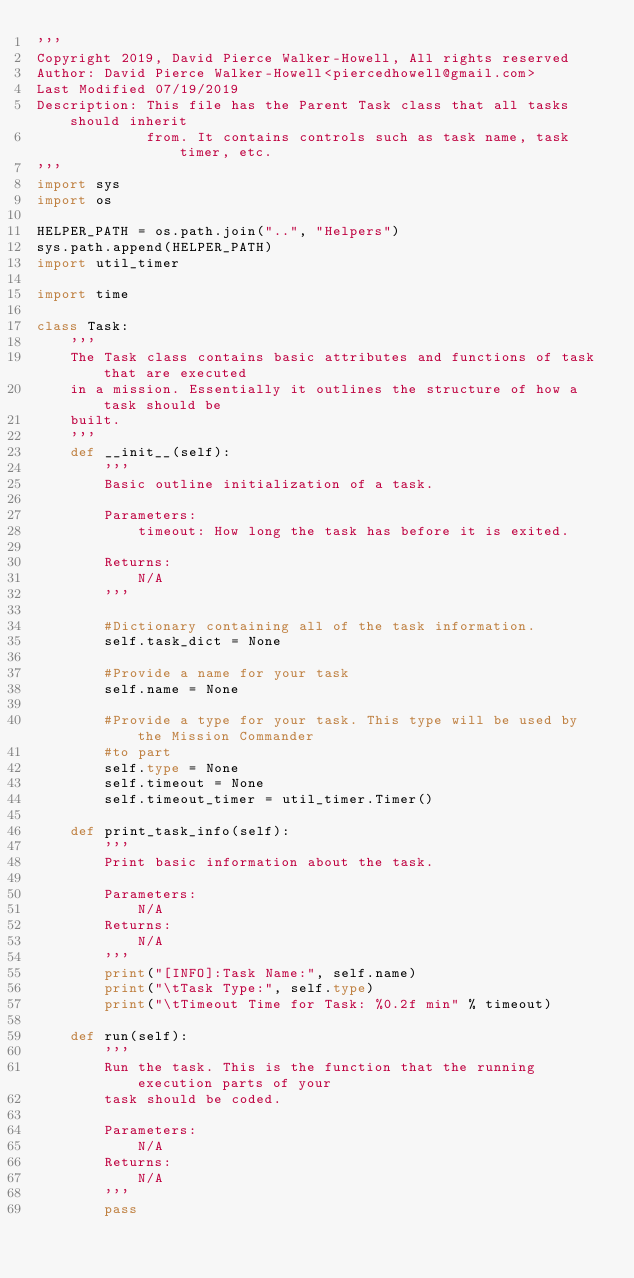Convert code to text. <code><loc_0><loc_0><loc_500><loc_500><_Python_>'''
Copyright 2019, David Pierce Walker-Howell, All rights reserved
Author: David Pierce Walker-Howell<piercedhowell@gmail.com>
Last Modified 07/19/2019
Description: This file has the Parent Task class that all tasks should inherit
             from. It contains controls such as task name, task timer, etc.
'''
import sys
import os

HELPER_PATH = os.path.join("..", "Helpers")
sys.path.append(HELPER_PATH)
import util_timer

import time

class Task:
    '''
    The Task class contains basic attributes and functions of task that are executed
    in a mission. Essentially it outlines the structure of how a task should be
    built.
    '''
    def __init__(self):
        '''
        Basic outline initialization of a task.

        Parameters:
            timeout: How long the task has before it is exited.

        Returns:
            N/A
        '''

        #Dictionary containing all of the task information.
        self.task_dict = None

        #Provide a name for your task
        self.name = None

        #Provide a type for your task. This type will be used by the Mission Commander
        #to part
        self.type = None
        self.timeout = None
        self.timeout_timer = util_timer.Timer()

    def print_task_info(self):
        '''
        Print basic information about the task.

        Parameters:
            N/A
        Returns:
            N/A
        '''
        print("[INFO]:Task Name:", self.name)
        print("\tTask Type:", self.type)
        print("\tTimeout Time for Task: %0.2f min" % timeout)

    def run(self):
        '''
        Run the task. This is the function that the running execution parts of your
        task should be coded.

        Parameters:
            N/A
        Returns:
            N/A
        '''
        pass
</code> 